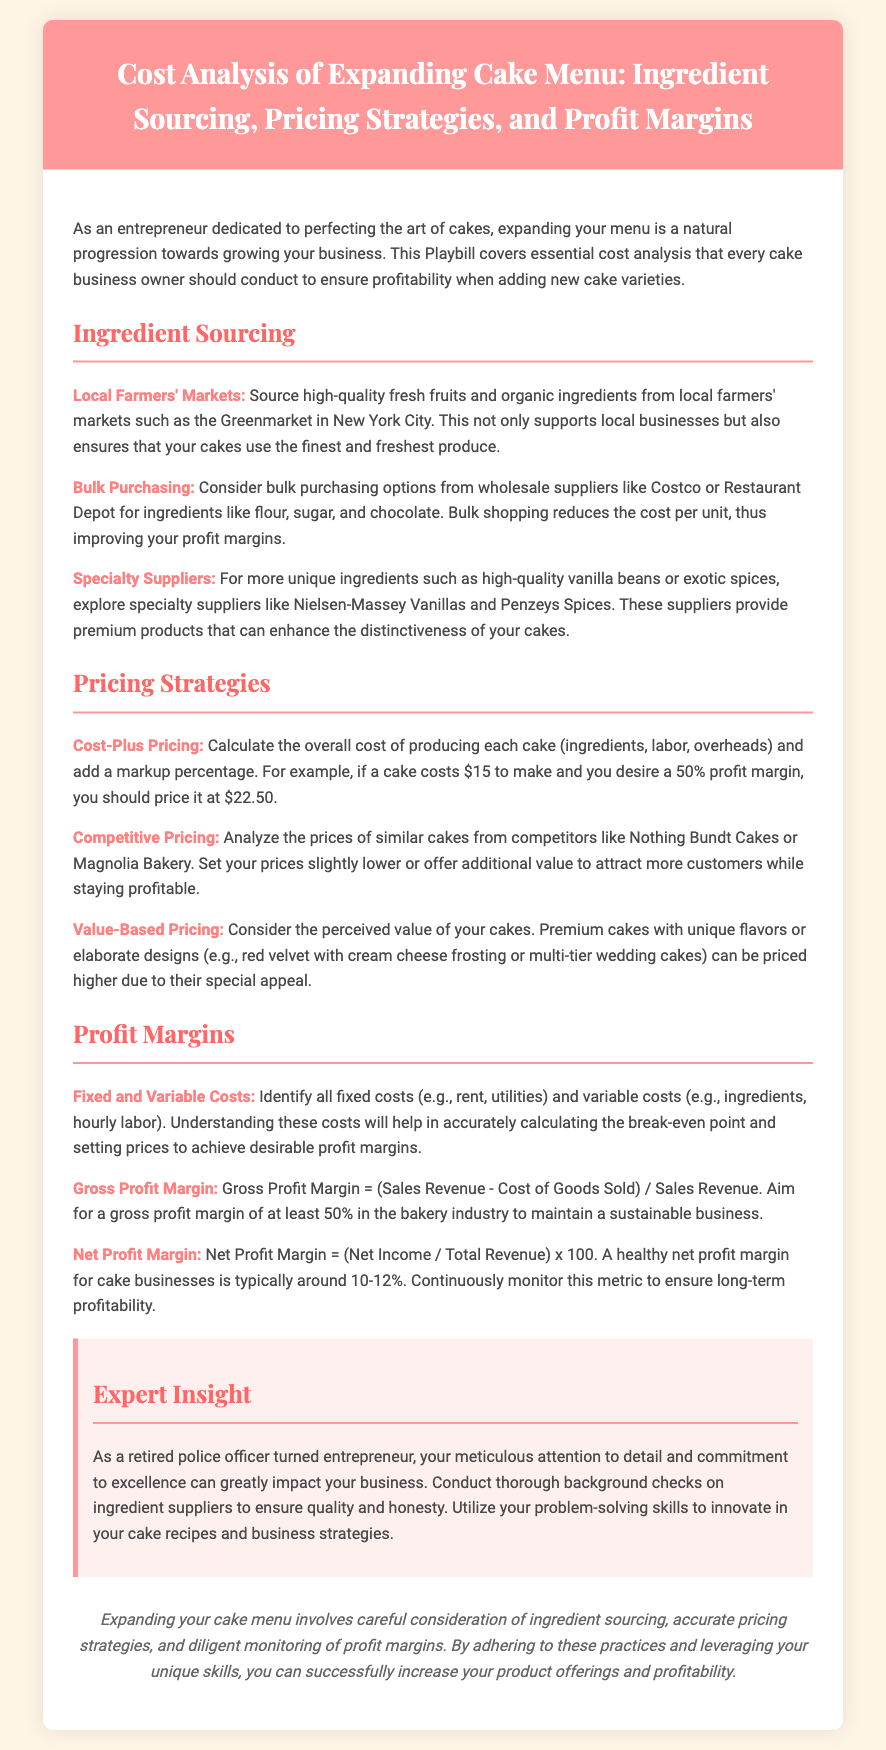what is the target gross profit margin in the bakery industry? The document states that the aim for a gross profit margin is at least 50% in the bakery industry.
Answer: 50% what is a potential sourcing option for ingredients? The document lists local farmers' markets as one option for sourcing high-quality fresh ingredients.
Answer: Local farmers' markets which pricing strategy considers perceived value? The document identifies value-based pricing as the strategy that considers the perceived value of cakes.
Answer: Value-Based Pricing what type of costs should be identified to understand profit margins? The document mentions identifying fixed and variable costs to understand profit margins.
Answer: Fixed and variable costs what is suggested for purchasing common cake ingredients? The document recommends considering bulk purchasing options from wholesale suppliers for common cake ingredients.
Answer: Bulk purchasing how much profit margin is typically healthy for cake businesses? The document mentions that a healthy net profit margin for cake businesses is typically around 10-12%.
Answer: 10-12% what is a recommended approach for innovative cake recipes? The document advises utilizing problem-solving skills to innovate in cake recipes and business strategies.
Answer: Utilize problem-solving skills what is the purpose of conducting background checks on ingredient suppliers? The document suggests conducting background checks to ensure quality and honesty from suppliers.
Answer: To ensure quality and honesty which supplier type provides premium products for cakes? Specialty suppliers are mentioned as providers of premium products for cakes.
Answer: Specialty suppliers 